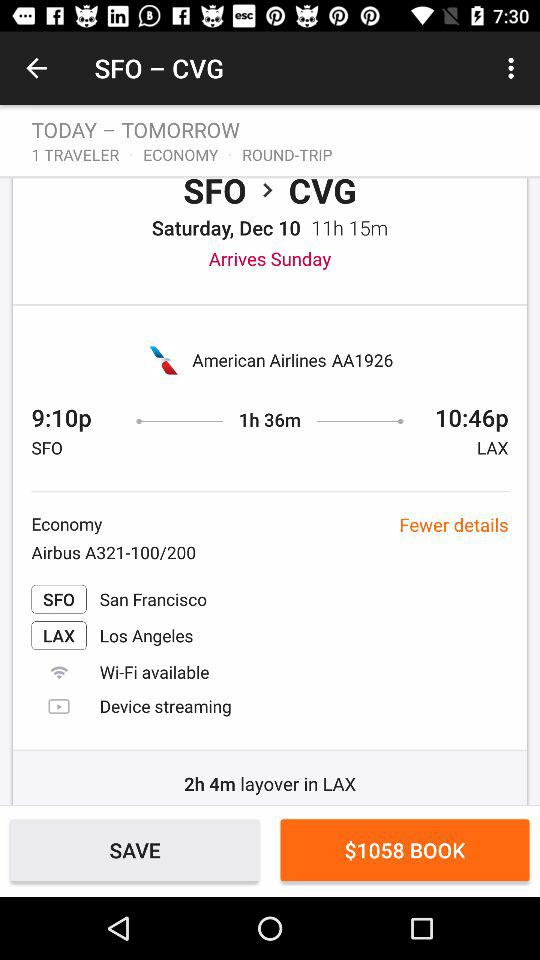How many hours of layover is there between flights?
Answer the question using a single word or phrase. 2h 4m 